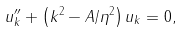Convert formula to latex. <formula><loc_0><loc_0><loc_500><loc_500>u _ { k } ^ { \prime \prime } + \left ( k ^ { 2 } - A / \eta ^ { 2 } \right ) u _ { k } = 0 ,</formula> 